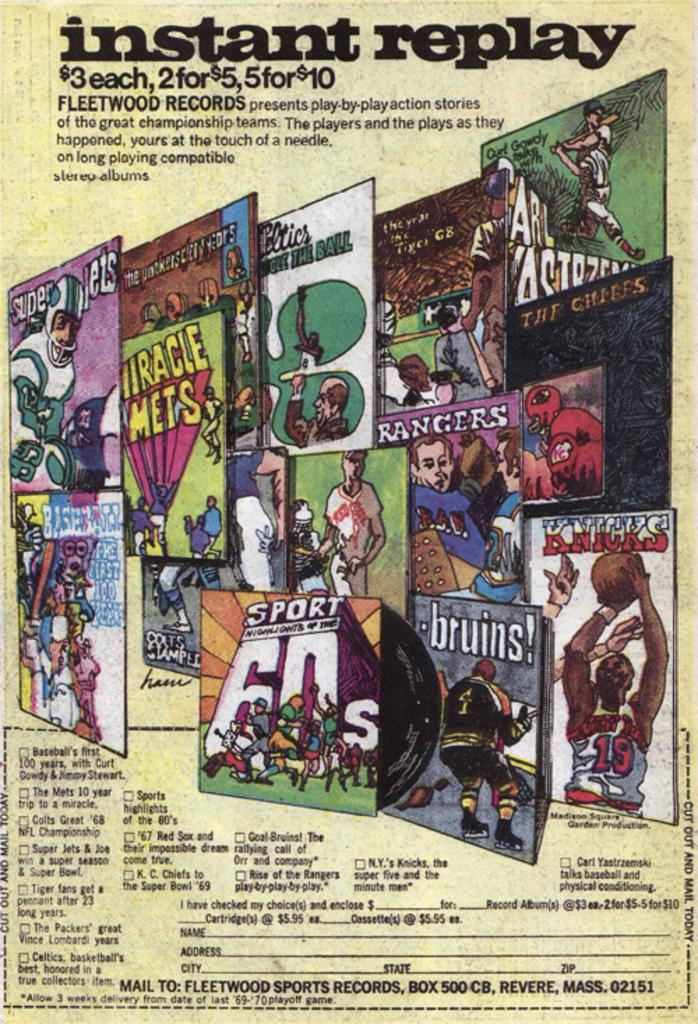<image>
Relay a brief, clear account of the picture shown. An old instant replay ad says that you can get two records for $5. 